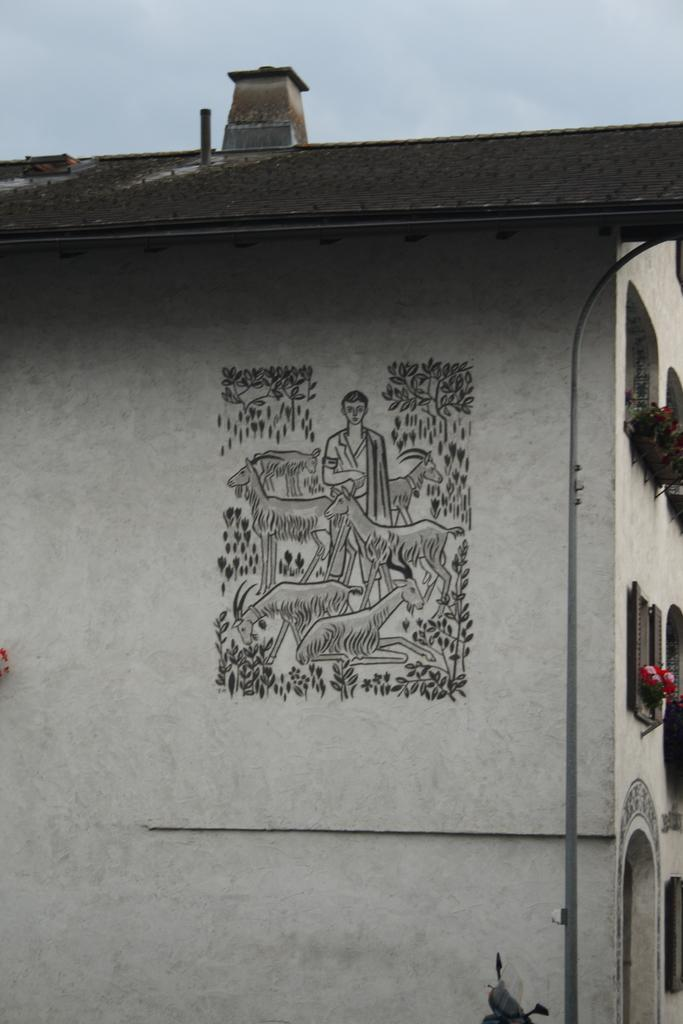What type of structure is present in the image? There is a building in the image. Can you describe any specific features of the building? The building has a design on the wall. What else can be seen in the image besides the building? There are objects in the image. What is visible in the background of the image? The sky is visible in the background of the image. What type of glass is being used to print the design on the building? There is no glass or printing process mentioned in the image. The design on the building is likely a painted or tiled pattern. 